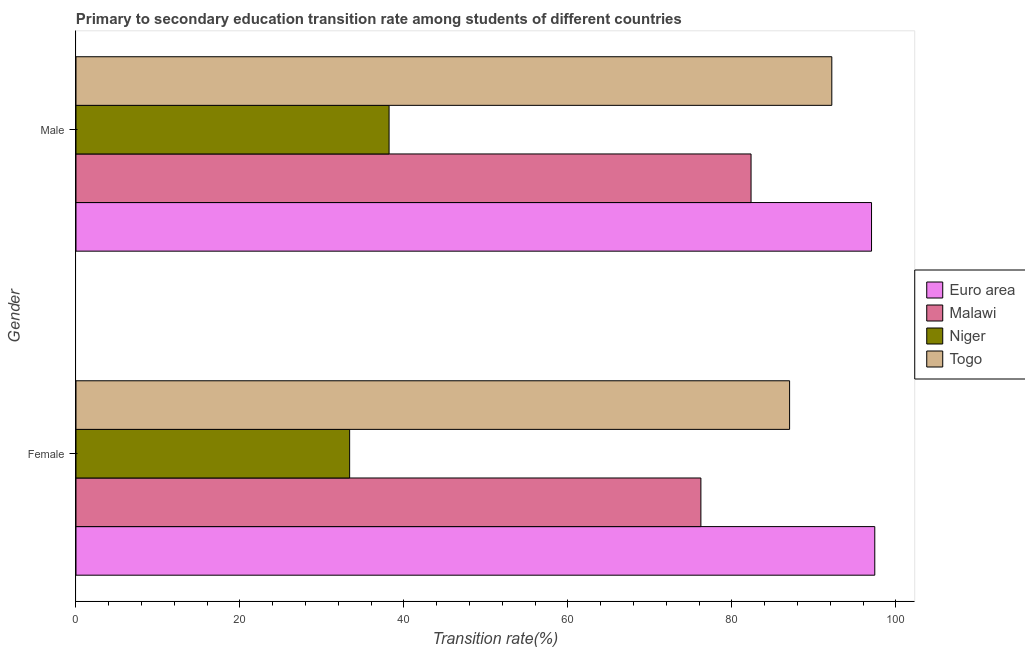How many bars are there on the 1st tick from the top?
Your response must be concise. 4. What is the label of the 2nd group of bars from the top?
Ensure brevity in your answer.  Female. What is the transition rate among female students in Euro area?
Make the answer very short. 97.44. Across all countries, what is the maximum transition rate among female students?
Your response must be concise. 97.44. Across all countries, what is the minimum transition rate among male students?
Your answer should be compact. 38.19. In which country was the transition rate among male students maximum?
Ensure brevity in your answer.  Euro area. In which country was the transition rate among female students minimum?
Provide a succinct answer. Niger. What is the total transition rate among female students in the graph?
Give a very brief answer. 294.09. What is the difference between the transition rate among female students in Malawi and that in Euro area?
Give a very brief answer. -21.21. What is the difference between the transition rate among female students in Malawi and the transition rate among male students in Togo?
Make the answer very short. -15.97. What is the average transition rate among female students per country?
Keep it short and to the point. 73.52. What is the difference between the transition rate among female students and transition rate among male students in Togo?
Make the answer very short. -5.15. In how many countries, is the transition rate among female students greater than 84 %?
Make the answer very short. 2. What is the ratio of the transition rate among male students in Togo to that in Malawi?
Give a very brief answer. 1.12. Is the transition rate among male students in Euro area less than that in Niger?
Give a very brief answer. No. In how many countries, is the transition rate among female students greater than the average transition rate among female students taken over all countries?
Ensure brevity in your answer.  3. What does the 2nd bar from the top in Male represents?
Make the answer very short. Niger. What does the 1st bar from the bottom in Female represents?
Offer a terse response. Euro area. How many bars are there?
Offer a very short reply. 8. Are all the bars in the graph horizontal?
Your answer should be compact. Yes. Are the values on the major ticks of X-axis written in scientific E-notation?
Give a very brief answer. No. Does the graph contain grids?
Offer a terse response. No. What is the title of the graph?
Your answer should be compact. Primary to secondary education transition rate among students of different countries. What is the label or title of the X-axis?
Make the answer very short. Transition rate(%). What is the Transition rate(%) in Euro area in Female?
Ensure brevity in your answer.  97.44. What is the Transition rate(%) in Malawi in Female?
Ensure brevity in your answer.  76.23. What is the Transition rate(%) of Niger in Female?
Your answer should be very brief. 33.38. What is the Transition rate(%) in Togo in Female?
Give a very brief answer. 87.05. What is the Transition rate(%) in Euro area in Male?
Ensure brevity in your answer.  97.04. What is the Transition rate(%) of Malawi in Male?
Your response must be concise. 82.34. What is the Transition rate(%) in Niger in Male?
Provide a short and direct response. 38.19. What is the Transition rate(%) in Togo in Male?
Ensure brevity in your answer.  92.2. Across all Gender, what is the maximum Transition rate(%) in Euro area?
Give a very brief answer. 97.44. Across all Gender, what is the maximum Transition rate(%) in Malawi?
Offer a terse response. 82.34. Across all Gender, what is the maximum Transition rate(%) of Niger?
Offer a terse response. 38.19. Across all Gender, what is the maximum Transition rate(%) in Togo?
Make the answer very short. 92.2. Across all Gender, what is the minimum Transition rate(%) of Euro area?
Your answer should be compact. 97.04. Across all Gender, what is the minimum Transition rate(%) of Malawi?
Offer a very short reply. 76.23. Across all Gender, what is the minimum Transition rate(%) in Niger?
Give a very brief answer. 33.38. Across all Gender, what is the minimum Transition rate(%) of Togo?
Give a very brief answer. 87.05. What is the total Transition rate(%) of Euro area in the graph?
Make the answer very short. 194.48. What is the total Transition rate(%) in Malawi in the graph?
Provide a succinct answer. 158.57. What is the total Transition rate(%) of Niger in the graph?
Offer a terse response. 71.57. What is the total Transition rate(%) in Togo in the graph?
Your response must be concise. 179.24. What is the difference between the Transition rate(%) of Euro area in Female and that in Male?
Your response must be concise. 0.4. What is the difference between the Transition rate(%) of Malawi in Female and that in Male?
Your response must be concise. -6.12. What is the difference between the Transition rate(%) in Niger in Female and that in Male?
Your response must be concise. -4.81. What is the difference between the Transition rate(%) of Togo in Female and that in Male?
Provide a short and direct response. -5.15. What is the difference between the Transition rate(%) in Euro area in Female and the Transition rate(%) in Malawi in Male?
Make the answer very short. 15.09. What is the difference between the Transition rate(%) of Euro area in Female and the Transition rate(%) of Niger in Male?
Keep it short and to the point. 59.25. What is the difference between the Transition rate(%) in Euro area in Female and the Transition rate(%) in Togo in Male?
Keep it short and to the point. 5.24. What is the difference between the Transition rate(%) in Malawi in Female and the Transition rate(%) in Niger in Male?
Offer a terse response. 38.03. What is the difference between the Transition rate(%) of Malawi in Female and the Transition rate(%) of Togo in Male?
Provide a succinct answer. -15.97. What is the difference between the Transition rate(%) of Niger in Female and the Transition rate(%) of Togo in Male?
Your answer should be compact. -58.82. What is the average Transition rate(%) of Euro area per Gender?
Ensure brevity in your answer.  97.24. What is the average Transition rate(%) in Malawi per Gender?
Offer a terse response. 79.28. What is the average Transition rate(%) in Niger per Gender?
Provide a succinct answer. 35.79. What is the average Transition rate(%) of Togo per Gender?
Provide a short and direct response. 89.62. What is the difference between the Transition rate(%) in Euro area and Transition rate(%) in Malawi in Female?
Your answer should be compact. 21.21. What is the difference between the Transition rate(%) of Euro area and Transition rate(%) of Niger in Female?
Ensure brevity in your answer.  64.06. What is the difference between the Transition rate(%) in Euro area and Transition rate(%) in Togo in Female?
Your answer should be very brief. 10.39. What is the difference between the Transition rate(%) in Malawi and Transition rate(%) in Niger in Female?
Your answer should be compact. 42.84. What is the difference between the Transition rate(%) in Malawi and Transition rate(%) in Togo in Female?
Offer a terse response. -10.82. What is the difference between the Transition rate(%) in Niger and Transition rate(%) in Togo in Female?
Give a very brief answer. -53.67. What is the difference between the Transition rate(%) of Euro area and Transition rate(%) of Malawi in Male?
Provide a succinct answer. 14.7. What is the difference between the Transition rate(%) of Euro area and Transition rate(%) of Niger in Male?
Your answer should be compact. 58.85. What is the difference between the Transition rate(%) of Euro area and Transition rate(%) of Togo in Male?
Your answer should be compact. 4.84. What is the difference between the Transition rate(%) of Malawi and Transition rate(%) of Niger in Male?
Make the answer very short. 44.15. What is the difference between the Transition rate(%) in Malawi and Transition rate(%) in Togo in Male?
Make the answer very short. -9.85. What is the difference between the Transition rate(%) in Niger and Transition rate(%) in Togo in Male?
Offer a terse response. -54.01. What is the ratio of the Transition rate(%) of Euro area in Female to that in Male?
Give a very brief answer. 1. What is the ratio of the Transition rate(%) in Malawi in Female to that in Male?
Make the answer very short. 0.93. What is the ratio of the Transition rate(%) in Niger in Female to that in Male?
Your response must be concise. 0.87. What is the ratio of the Transition rate(%) in Togo in Female to that in Male?
Keep it short and to the point. 0.94. What is the difference between the highest and the second highest Transition rate(%) in Euro area?
Keep it short and to the point. 0.4. What is the difference between the highest and the second highest Transition rate(%) of Malawi?
Your response must be concise. 6.12. What is the difference between the highest and the second highest Transition rate(%) of Niger?
Give a very brief answer. 4.81. What is the difference between the highest and the second highest Transition rate(%) of Togo?
Provide a succinct answer. 5.15. What is the difference between the highest and the lowest Transition rate(%) of Euro area?
Your answer should be compact. 0.4. What is the difference between the highest and the lowest Transition rate(%) in Malawi?
Your answer should be very brief. 6.12. What is the difference between the highest and the lowest Transition rate(%) in Niger?
Provide a short and direct response. 4.81. What is the difference between the highest and the lowest Transition rate(%) in Togo?
Your answer should be very brief. 5.15. 